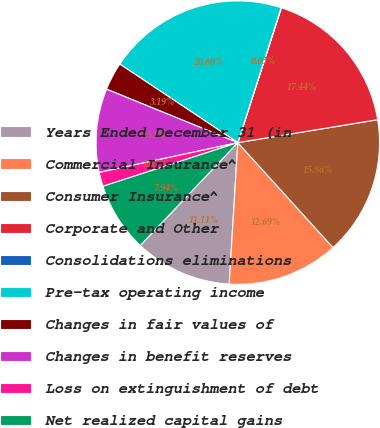<chart> <loc_0><loc_0><loc_500><loc_500><pie_chart><fcel>Years Ended December 31 (in<fcel>Commercial Insurance^<fcel>Consumer Insurance^<fcel>Corporate and Other<fcel>Consolidations eliminations<fcel>Pre-tax operating income<fcel>Changes in fair values of<fcel>Changes in benefit reserves<fcel>Loss on extinguishment of debt<fcel>Net realized capital gains<nl><fcel>11.11%<fcel>12.69%<fcel>15.86%<fcel>17.44%<fcel>0.03%<fcel>20.6%<fcel>3.19%<fcel>9.53%<fcel>1.61%<fcel>7.94%<nl></chart> 